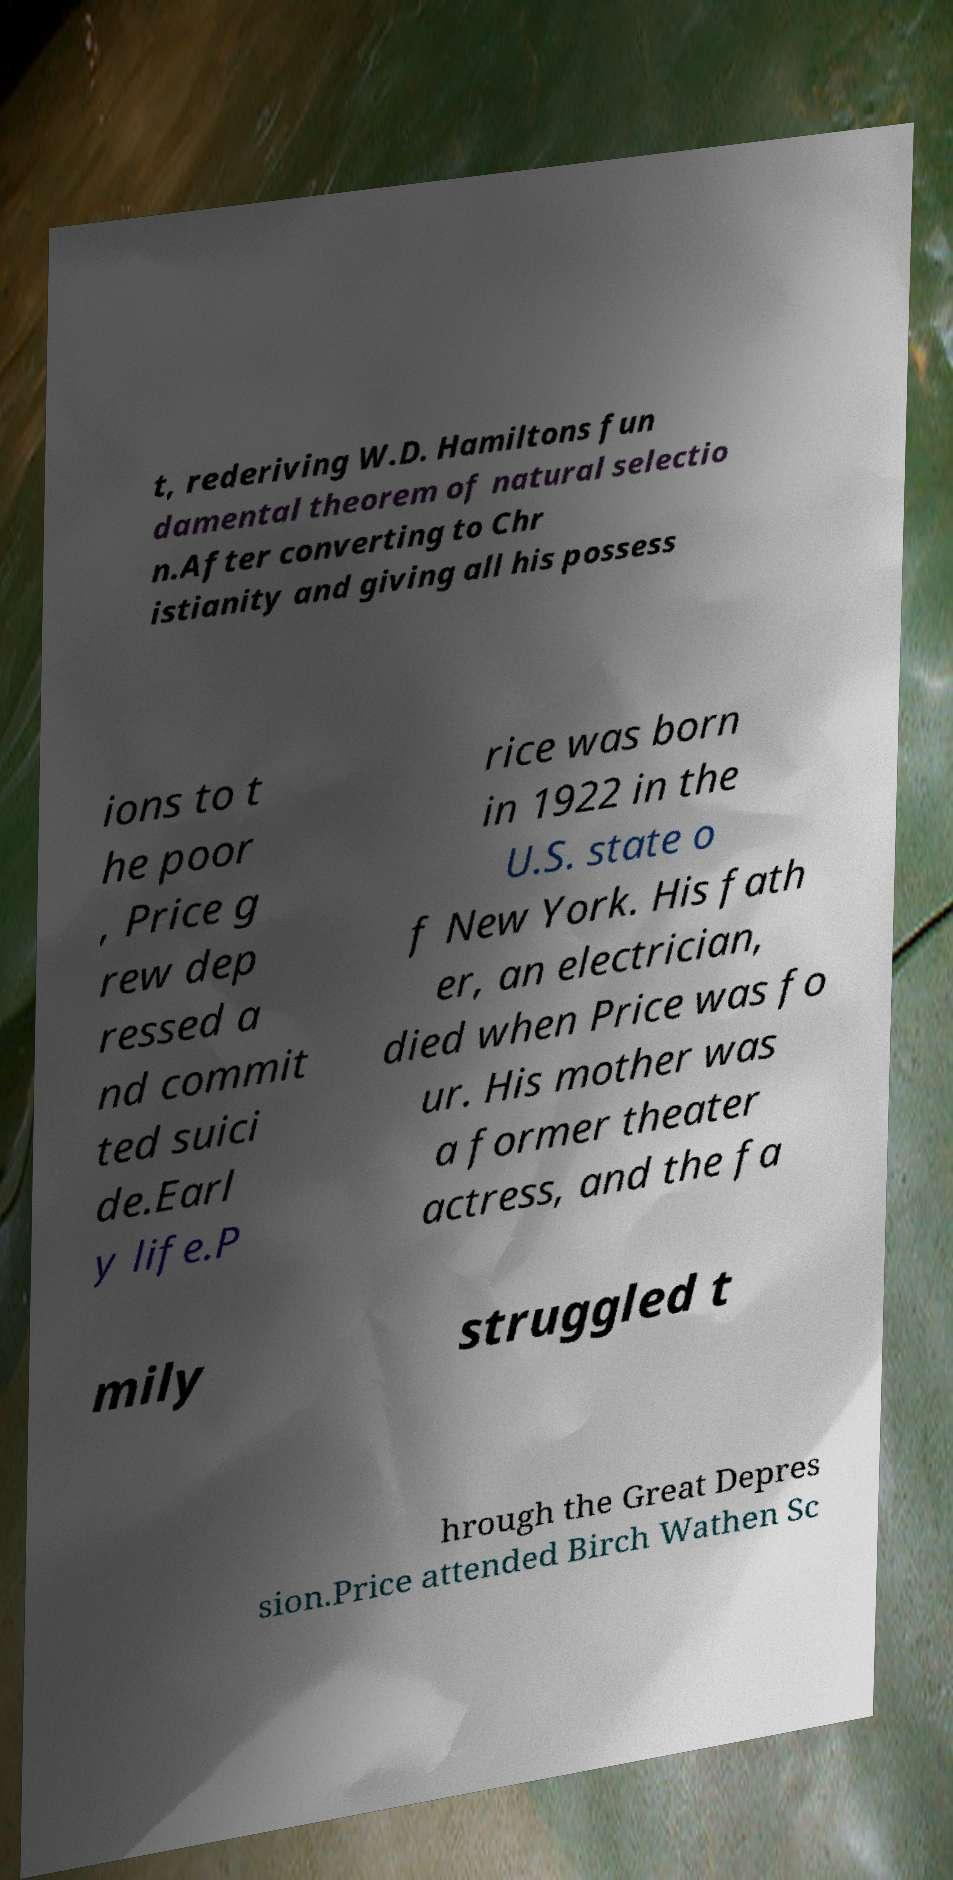Please read and relay the text visible in this image. What does it say? t, rederiving W.D. Hamiltons fun damental theorem of natural selectio n.After converting to Chr istianity and giving all his possess ions to t he poor , Price g rew dep ressed a nd commit ted suici de.Earl y life.P rice was born in 1922 in the U.S. state o f New York. His fath er, an electrician, died when Price was fo ur. His mother was a former theater actress, and the fa mily struggled t hrough the Great Depres sion.Price attended Birch Wathen Sc 